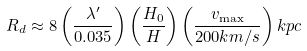<formula> <loc_0><loc_0><loc_500><loc_500>R _ { d } \approx 8 \left ( \frac { \lambda ^ { \prime } } { 0 . 0 3 5 } \right ) \left ( \frac { H _ { 0 } } { H } \right ) \left ( \frac { v _ { \max } } { 2 0 0 k m / s } \right ) k p c</formula> 